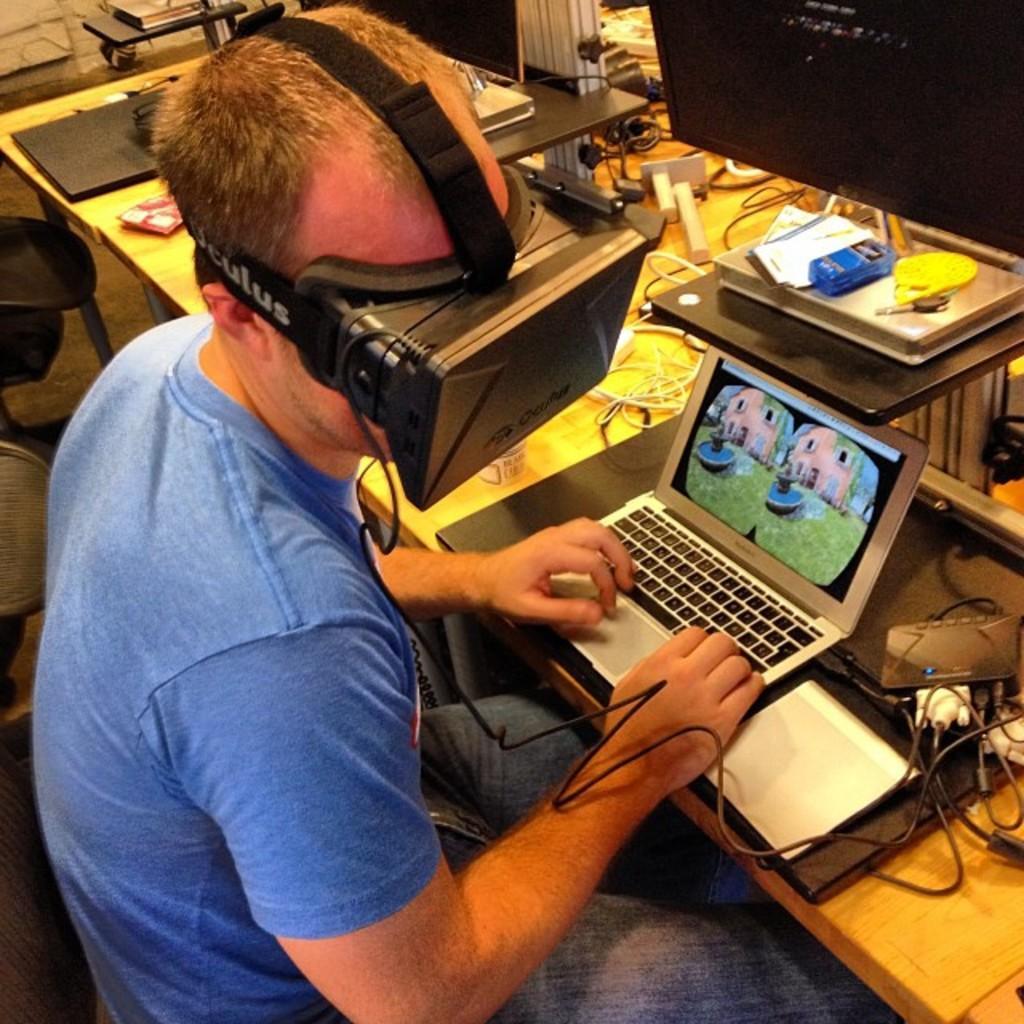Could you give a brief overview of what you see in this image? On the left of this picture we can see a person wearing blue color t-shirt and an electronic device, sitting and seems to be working on a laptop and we can see there are some objects placed on the top of the table. In the background we can see there are some objects placed on the ground. 